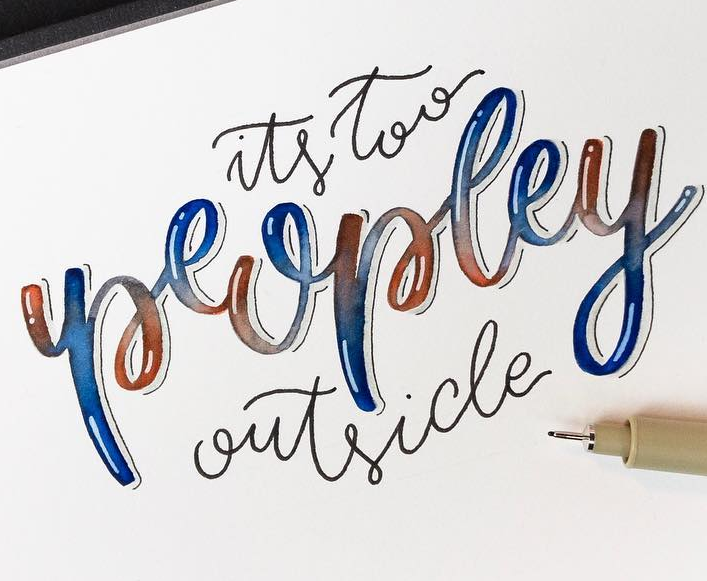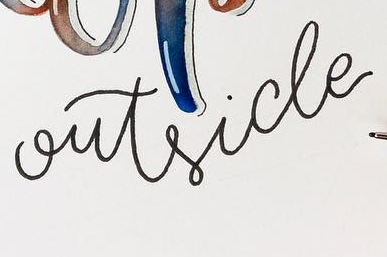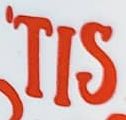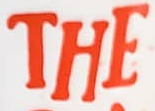What text is displayed in these images sequentially, separated by a semicolon? peopley; outside; 'TIS; THE 